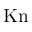Convert formula to latex. <formula><loc_0><loc_0><loc_500><loc_500>K n</formula> 